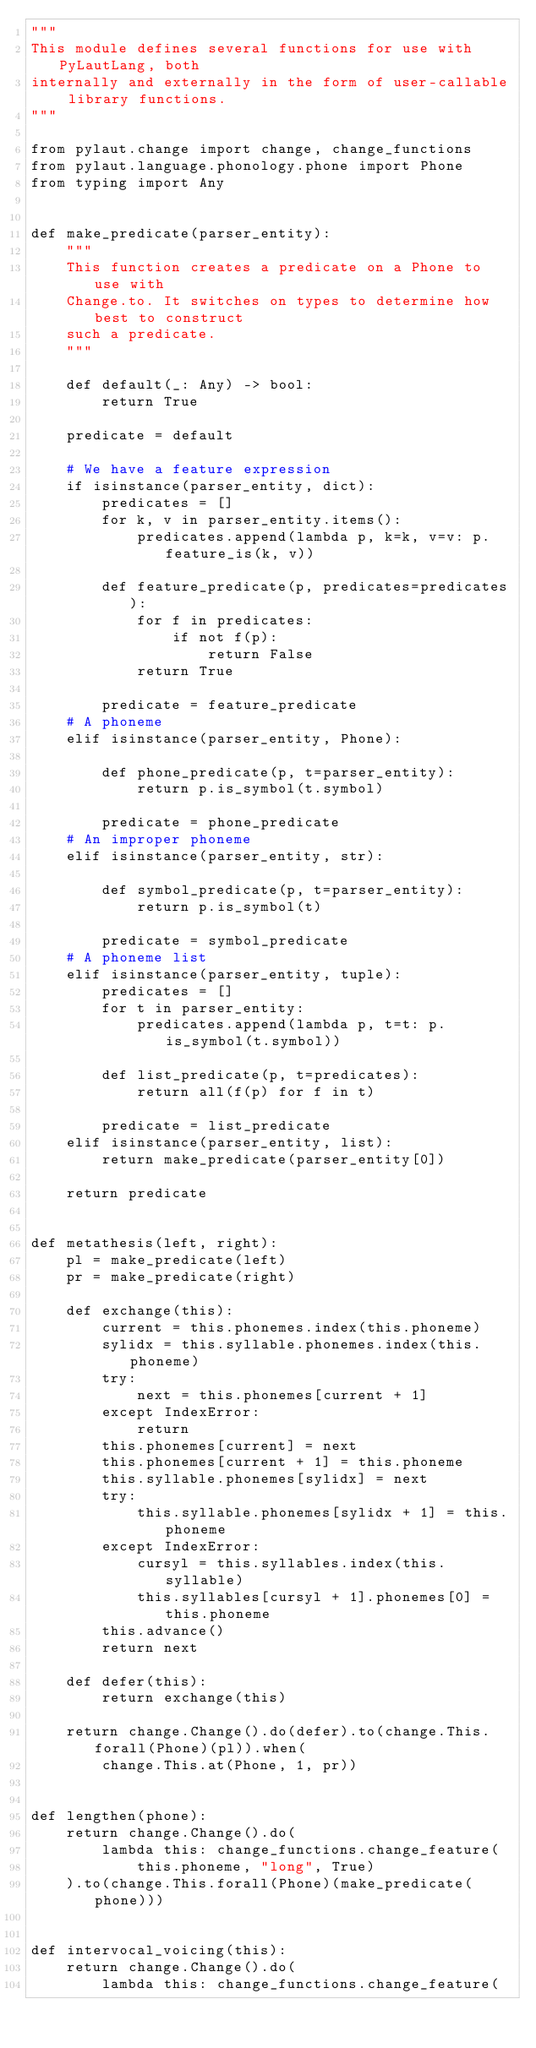Convert code to text. <code><loc_0><loc_0><loc_500><loc_500><_Python_>"""
This module defines several functions for use with PyLautLang, both
internally and externally in the form of user-callable library functions.
"""

from pylaut.change import change, change_functions
from pylaut.language.phonology.phone import Phone
from typing import Any


def make_predicate(parser_entity):
    """
    This function creates a predicate on a Phone to use with
    Change.to. It switches on types to determine how best to construct
    such a predicate.
    """

    def default(_: Any) -> bool:
        return True

    predicate = default

    # We have a feature expression
    if isinstance(parser_entity, dict):
        predicates = []
        for k, v in parser_entity.items():
            predicates.append(lambda p, k=k, v=v: p.feature_is(k, v))

        def feature_predicate(p, predicates=predicates):
            for f in predicates:
                if not f(p):
                    return False
            return True

        predicate = feature_predicate
    # A phoneme
    elif isinstance(parser_entity, Phone):

        def phone_predicate(p, t=parser_entity):
            return p.is_symbol(t.symbol)

        predicate = phone_predicate
    # An improper phoneme
    elif isinstance(parser_entity, str):

        def symbol_predicate(p, t=parser_entity):
            return p.is_symbol(t)

        predicate = symbol_predicate
    # A phoneme list
    elif isinstance(parser_entity, tuple):
        predicates = []
        for t in parser_entity:
            predicates.append(lambda p, t=t: p.is_symbol(t.symbol))

        def list_predicate(p, t=predicates):
            return all(f(p) for f in t)

        predicate = list_predicate
    elif isinstance(parser_entity, list):
        return make_predicate(parser_entity[0])

    return predicate


def metathesis(left, right):
    pl = make_predicate(left)
    pr = make_predicate(right)

    def exchange(this):
        current = this.phonemes.index(this.phoneme)
        sylidx = this.syllable.phonemes.index(this.phoneme)
        try:
            next = this.phonemes[current + 1]
        except IndexError:
            return
        this.phonemes[current] = next
        this.phonemes[current + 1] = this.phoneme
        this.syllable.phonemes[sylidx] = next
        try:
            this.syllable.phonemes[sylidx + 1] = this.phoneme
        except IndexError:
            cursyl = this.syllables.index(this.syllable)
            this.syllables[cursyl + 1].phonemes[0] = this.phoneme
        this.advance()
        return next

    def defer(this):
        return exchange(this)

    return change.Change().do(defer).to(change.This.forall(Phone)(pl)).when(
        change.This.at(Phone, 1, pr))


def lengthen(phone):
    return change.Change().do(
        lambda this: change_functions.change_feature(
            this.phoneme, "long", True)
    ).to(change.This.forall(Phone)(make_predicate(phone)))


def intervocal_voicing(this):
    return change.Change().do(
        lambda this: change_functions.change_feature(</code> 